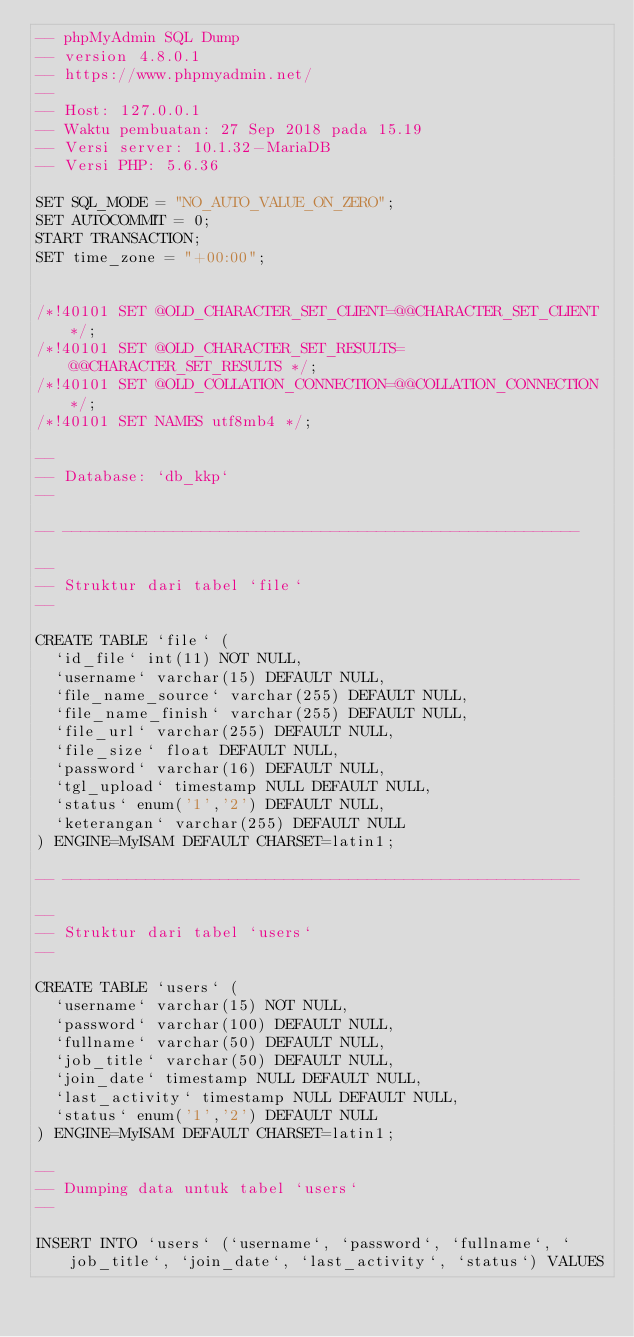<code> <loc_0><loc_0><loc_500><loc_500><_SQL_>-- phpMyAdmin SQL Dump
-- version 4.8.0.1
-- https://www.phpmyadmin.net/
--
-- Host: 127.0.0.1
-- Waktu pembuatan: 27 Sep 2018 pada 15.19
-- Versi server: 10.1.32-MariaDB
-- Versi PHP: 5.6.36

SET SQL_MODE = "NO_AUTO_VALUE_ON_ZERO";
SET AUTOCOMMIT = 0;
START TRANSACTION;
SET time_zone = "+00:00";


/*!40101 SET @OLD_CHARACTER_SET_CLIENT=@@CHARACTER_SET_CLIENT */;
/*!40101 SET @OLD_CHARACTER_SET_RESULTS=@@CHARACTER_SET_RESULTS */;
/*!40101 SET @OLD_COLLATION_CONNECTION=@@COLLATION_CONNECTION */;
/*!40101 SET NAMES utf8mb4 */;

--
-- Database: `db_kkp`
--

-- --------------------------------------------------------

--
-- Struktur dari tabel `file`
--

CREATE TABLE `file` (
  `id_file` int(11) NOT NULL,
  `username` varchar(15) DEFAULT NULL,
  `file_name_source` varchar(255) DEFAULT NULL,
  `file_name_finish` varchar(255) DEFAULT NULL,
  `file_url` varchar(255) DEFAULT NULL,
  `file_size` float DEFAULT NULL,
  `password` varchar(16) DEFAULT NULL,
  `tgl_upload` timestamp NULL DEFAULT NULL,
  `status` enum('1','2') DEFAULT NULL,
  `keterangan` varchar(255) DEFAULT NULL
) ENGINE=MyISAM DEFAULT CHARSET=latin1;

-- --------------------------------------------------------

--
-- Struktur dari tabel `users`
--

CREATE TABLE `users` (
  `username` varchar(15) NOT NULL,
  `password` varchar(100) DEFAULT NULL,
  `fullname` varchar(50) DEFAULT NULL,
  `job_title` varchar(50) DEFAULT NULL,
  `join_date` timestamp NULL DEFAULT NULL,
  `last_activity` timestamp NULL DEFAULT NULL,
  `status` enum('1','2') DEFAULT NULL
) ENGINE=MyISAM DEFAULT CHARSET=latin1;

--
-- Dumping data untuk tabel `users`
--

INSERT INTO `users` (`username`, `password`, `fullname`, `job_title`, `join_date`, `last_activity`, `status`) VALUES</code> 